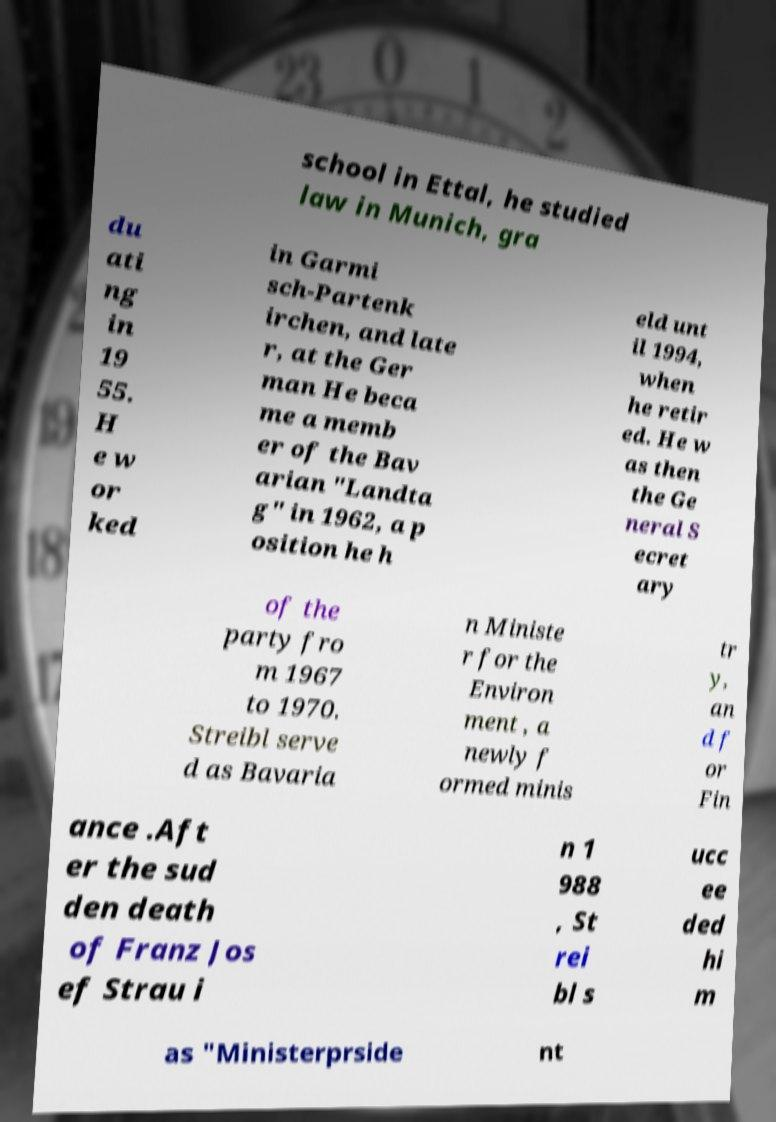Can you read and provide the text displayed in the image?This photo seems to have some interesting text. Can you extract and type it out for me? school in Ettal, he studied law in Munich, gra du ati ng in 19 55. H e w or ked in Garmi sch-Partenk irchen, and late r, at the Ger man He beca me a memb er of the Bav arian "Landta g" in 1962, a p osition he h eld unt il 1994, when he retir ed. He w as then the Ge neral S ecret ary of the party fro m 1967 to 1970. Streibl serve d as Bavaria n Ministe r for the Environ ment , a newly f ormed minis tr y, an d f or Fin ance .Aft er the sud den death of Franz Jos ef Strau i n 1 988 , St rei bl s ucc ee ded hi m as "Ministerprside nt 